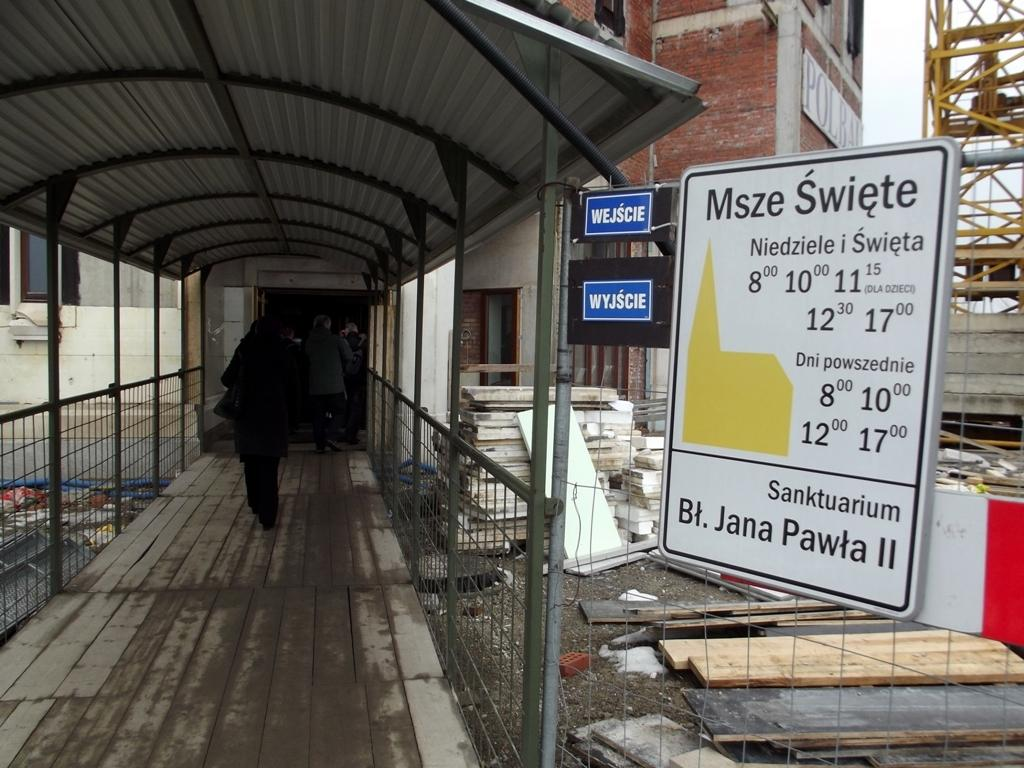What type of structures can be seen in the image? There are buildings in the image. What is the purpose of the large machine in the image? The image features a construction crane, which is used for lifting and moving heavy materials during construction. What can be seen in the sky in the image? The sky is visible in the image. What might provide information or guidance in the image? There are information boards in the image. What are the people in the image doing? Persons are walking on a walkway bridge in the image. What type of cooking equipment is present in the image? Grills are present in the image. What type of small shelter is visible in the image? There is a shed in the image. What type of pipe is visible in the image? There is no pipe present in the image. What type of cannon is being used by the person in the image? There is no cannon present in the image, and no person is depicted using one. 